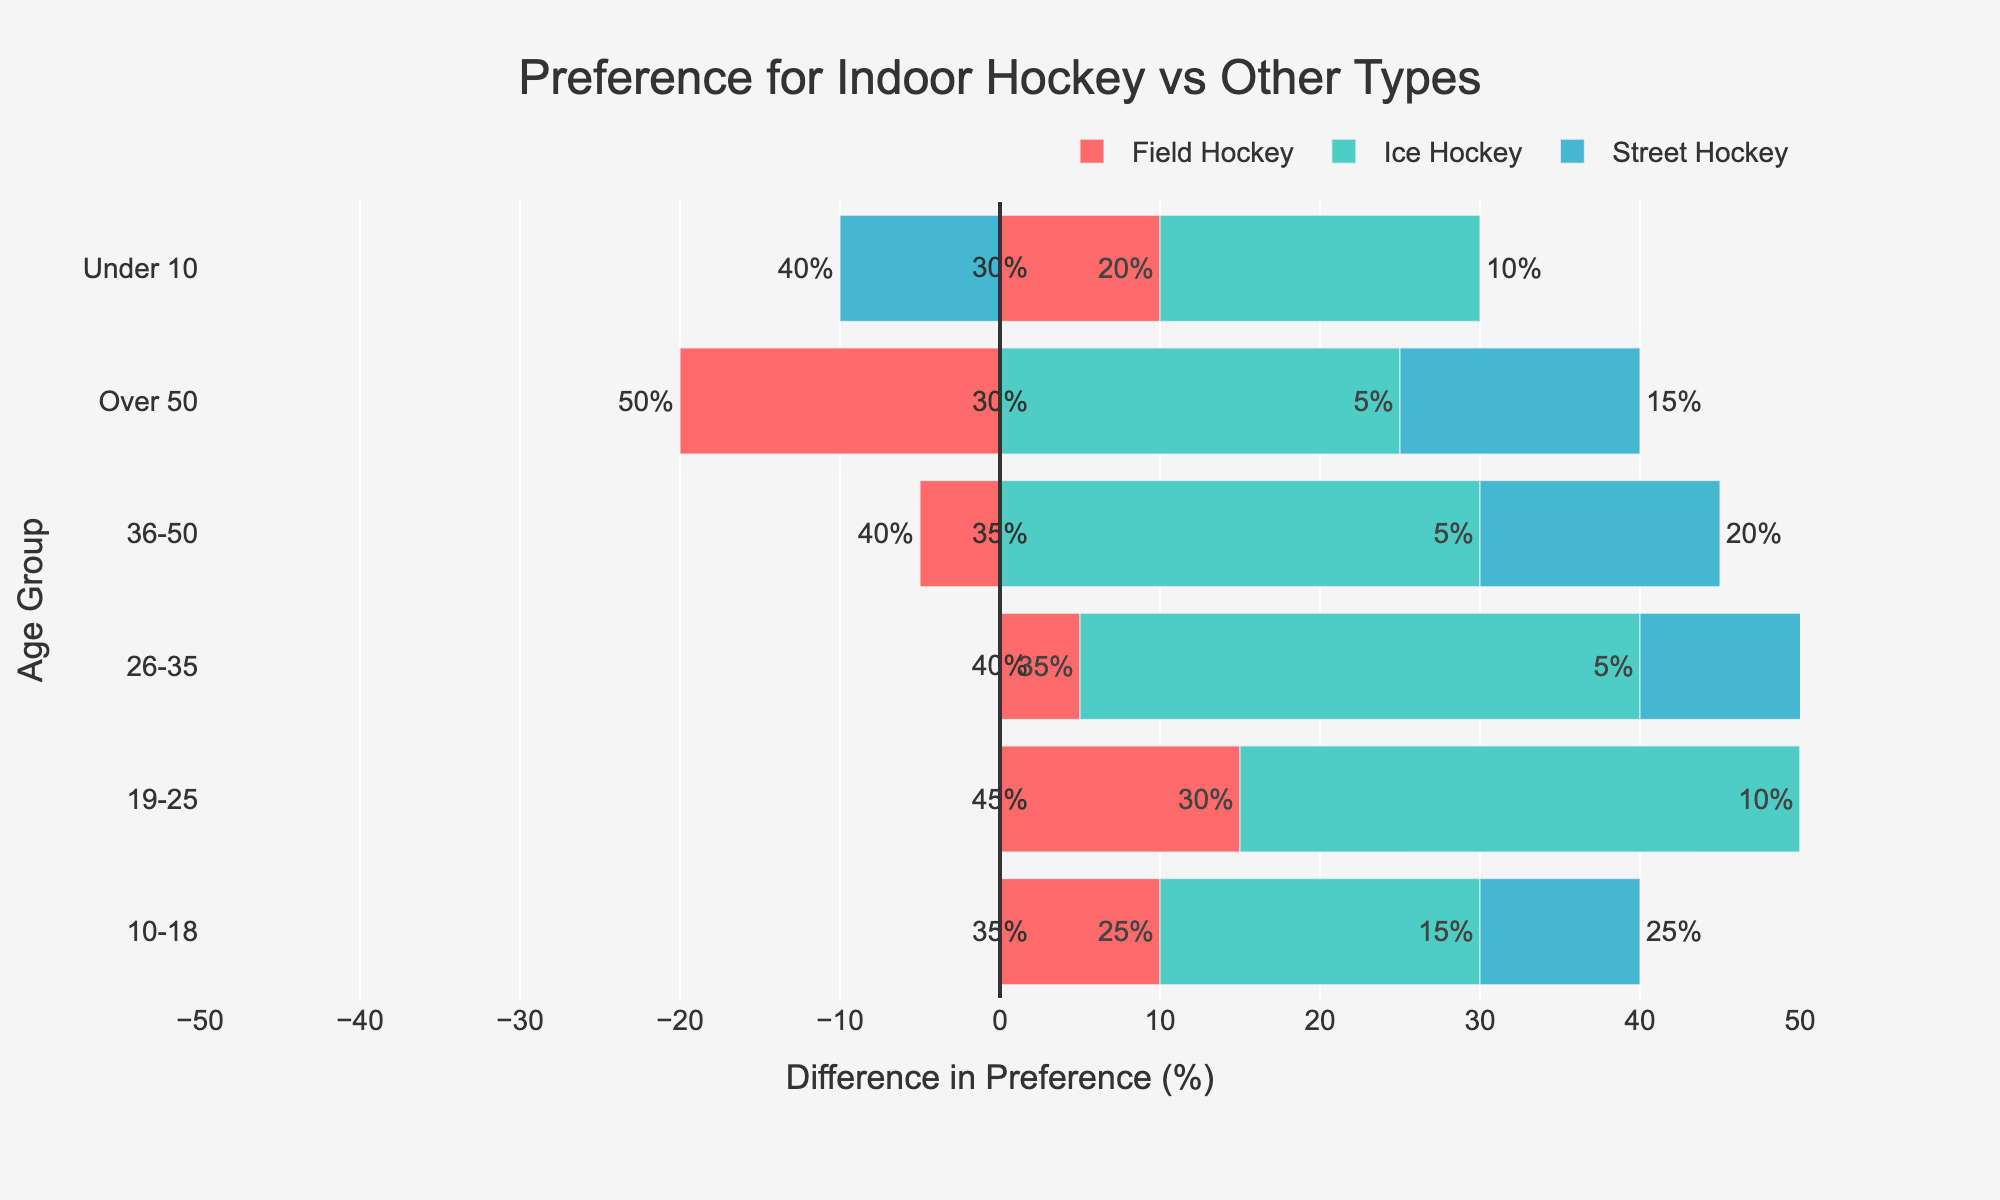Which age group has the highest preference for indoor hockey? In the figure, find the bar that represents indoor hockey for each age group and look for the longest bar. The age group 19-25 shows the longest bar for indoor hockey.
Answer: 19-25 How does the preference for indoor hockey compare to field hockey in the 26-35 age group? For the 26-35 age group, locate the bars representing indoor hockey and field hockey. The indoor hockey bar is slightly longer than the field hockey bar, indicating a higher preference.
Answer: Indoor hockey is preferred more Which age group shows the most balanced preference between indoor hockey and street hockey? Check each age group by comparing the lengths of the bars for indoor hockey and street hockey. The 10-18 age group has both bars of comparable length.
Answer: 10-18 What's the difference in preference percentage for indoor hockey and ice hockey in the Under 10 age group? Identify the bars for the Under 10 age group. Compare the indoor hockey bar to the ice hockey bar. Indoor hockey is at 30%, ice hockey is at 10%. The difference is 30 - 10 = 20%.
Answer: 20% Across all age groups, which type of hockey is least preferred compared to indoor hockey? Check the lengths of the bars for each type of hockey in comparison to indoor hockey across all age groups. Ice hockey consistently shows the smallest difference compared to indoor hockey.
Answer: Ice hockey What is the total percentage for street hockey preference across all age groups? Sum up the street hockey percentages from each age group: 40 + 25 + 15 + 20 + 15 = 115%.
Answer: 115% Which age group has the smallest difference in preference between indoor hockey and field hockey? Compare the differences in bar lengths for each age group between indoor hockey and field hockey. The Under 10 age group shows the smallest visible difference.
Answer: Under 10 Is there an age group where indoor hockey is less preferred than another type of hockey? For each age group, check if the indoor hockey bar is shorter than any other type. In each age group, the indoor hockey bar is either the longest or equal in length compared to the others.
Answer: No How much more preferred is indoor hockey than street hockey in the 19-25 age group? Compare the bars for indoor hockey and street hockey in 19-25. Indoor hockey is at 45% and street hockey is at 15%. The difference is 45 - 15 = 30%.
Answer: 30% Which age group has the highest difference in preference between indoor hockey and another type of hockey? Calculate the difference between indoor hockey and the least preferred type in each age group and find the maximum difference. For the 19-25 age group, the difference between indoor hockey (45%) and ice hockey (10%) is 35%, which is the highest.
Answer: 19-25 